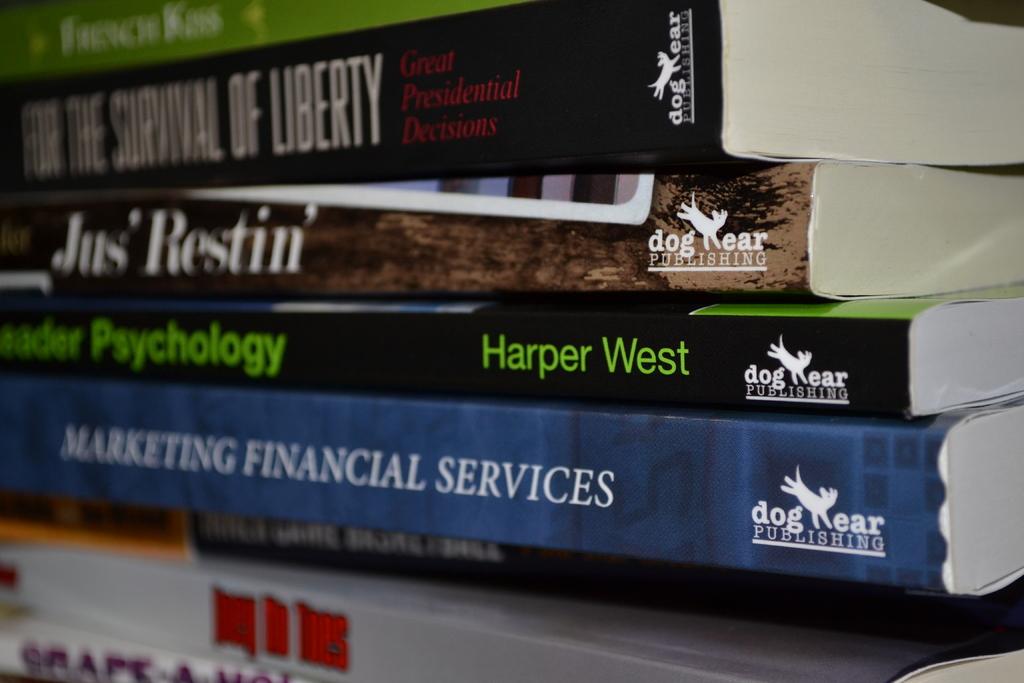Does dog ear publish college textbooks?
Give a very brief answer. Yes. 